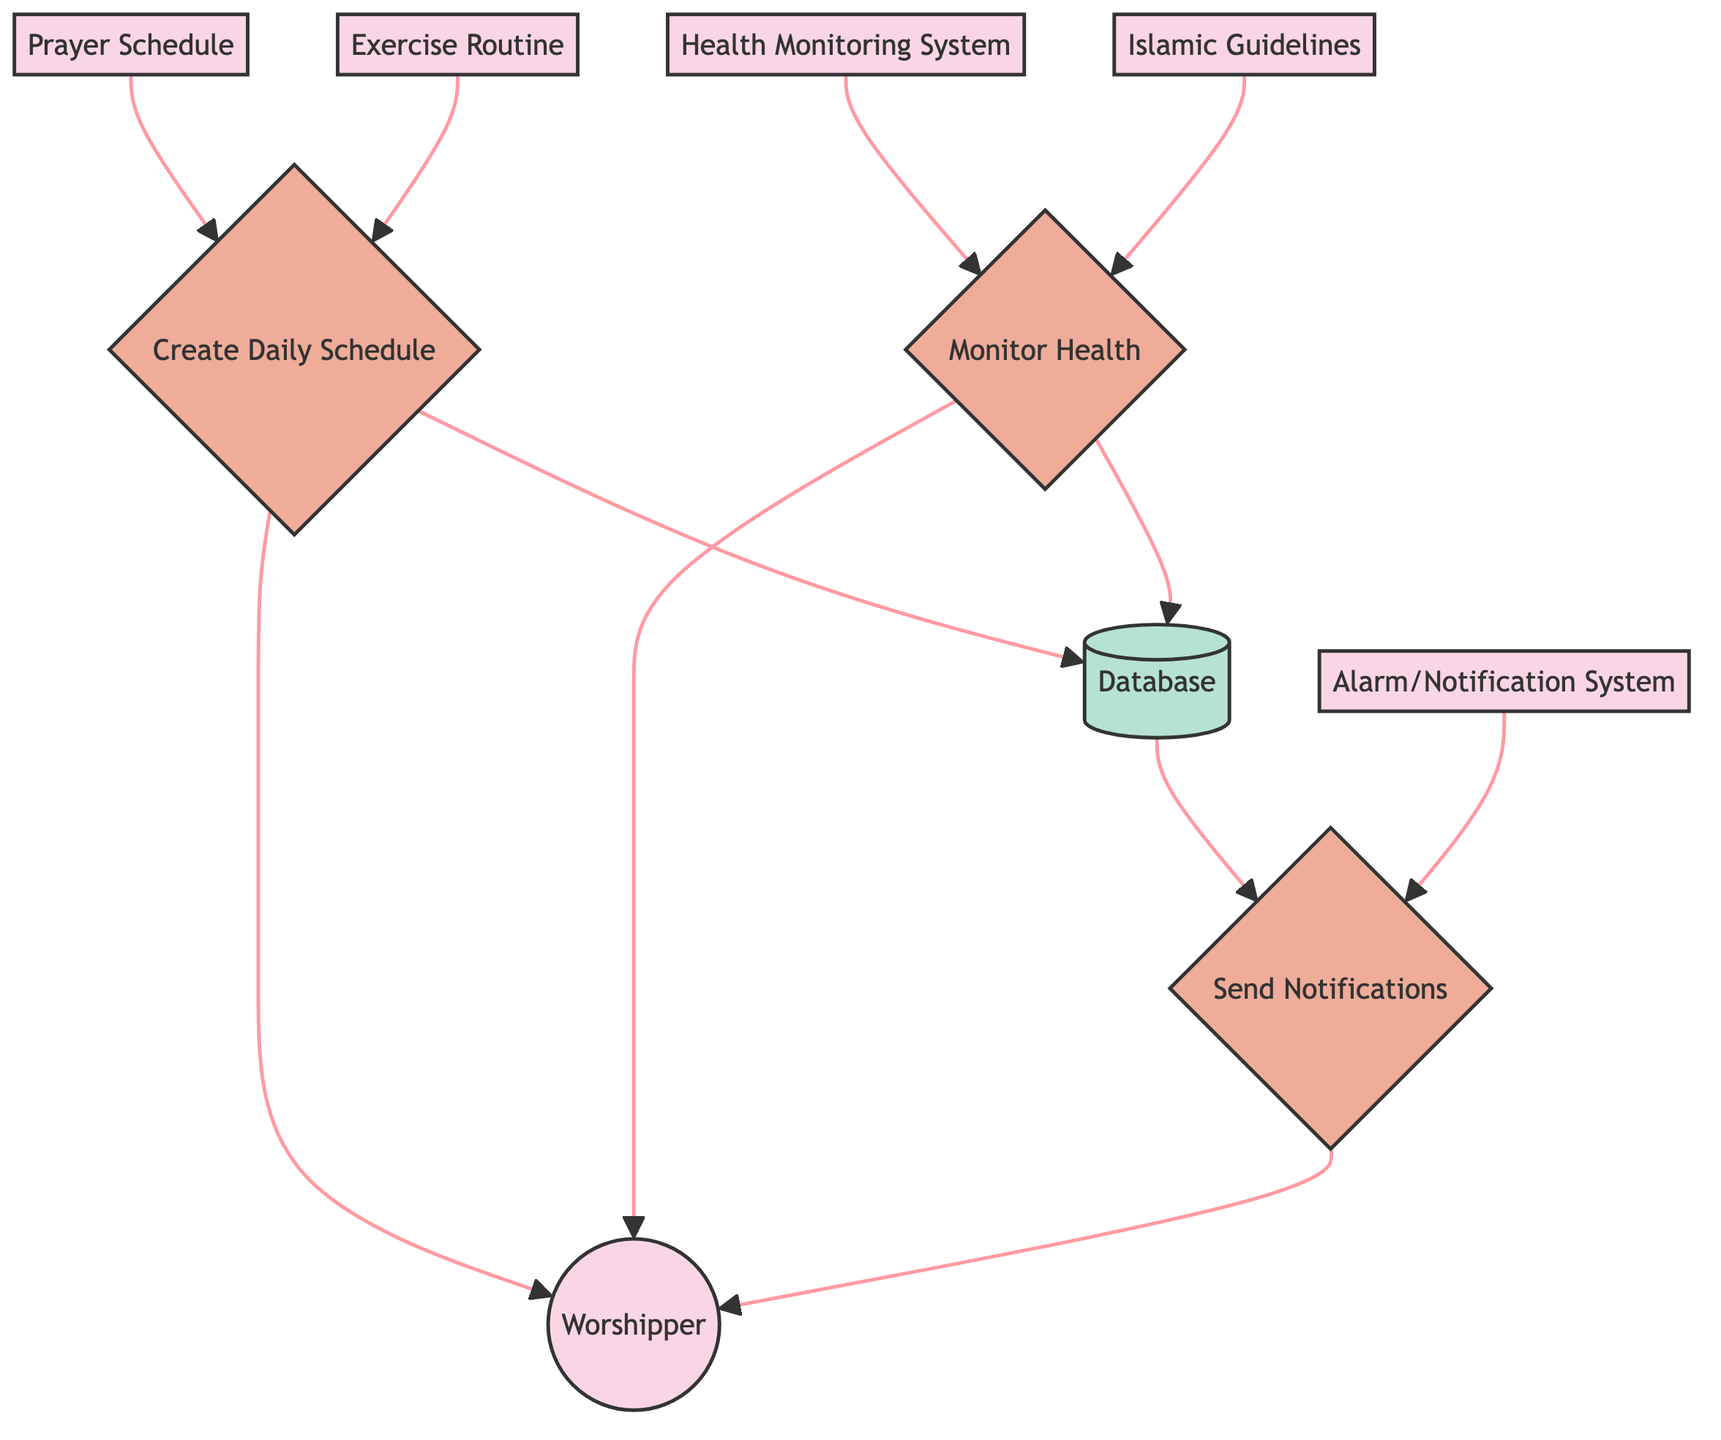What are the two inputs for the process "Create Daily Schedule"? The process "Create Daily Schedule" receives two inputs: "Prayer Schedule" and "Exercise Routine." These inputs provide the necessary information to develop the daily integrated schedule.
Answer: Prayer Schedule and Exercise Routine How many processes are present in this diagram? The diagram contains three processes: "Create Daily Schedule," "Monitor Health," and "Send Notifications." Counting these gives the total number of processes.
Answer: 3 Who receives the output from "Send Notifications"? The output from the "Send Notifications" process is delivered to the "Worshipper." This is indicated by the arrow directed towards the Worshipper entity from the Send Notifications process.
Answer: Worshipper What does the "Monitor Health" process output? The "Monitor Health" process outputs "Health Report." This output is generated after analyzing the inputs from health monitoring system and Islamic guidelines, delivering the report back to the worshipper.
Answer: Health Report Which entity provides the guidelines for maintaining physical health? The entity that provides guidelines for maintaining physical health is "Islamic Guidelines." This entity informs the "Monitor Health" process on appropriate health practices according to Islamic teachings.
Answer: Islamic Guidelines How does the "Health Monitoring System" contribute to the diagram? The "Health Monitoring System" acts as an input to the "Monitor Health" process, providing health data necessary for assessment. This relationship is indicated by the direct arrow from the health monitoring system to the process.
Answer: Input for Monitor Health What is the purpose of the "Alarm/Notification System"? The "Alarm/Notification System" serves to send alerts as part of the "Send Notifications" process based on the daily integrated schedule. It ensures the Worshipper is informed of upcoming prayer and exercise times.
Answer: Send alerts How many entities are in the diagram? The diagram includes six entities: "Worshipper," "Prayer Schedule," "Exercise Routine," "Islamic Guidelines," "Health Monitoring System," and "Alarm/Notification System." Counting these gives the total number of entities.
Answer: 6 What is the final output of the "Create Daily Schedule" process? The final output of the "Create Daily Schedule" process is "Daily Integrated Schedule." This output, which combines both prayer and exercise activities, is delivered to the Worshipper.
Answer: Daily Integrated Schedule 